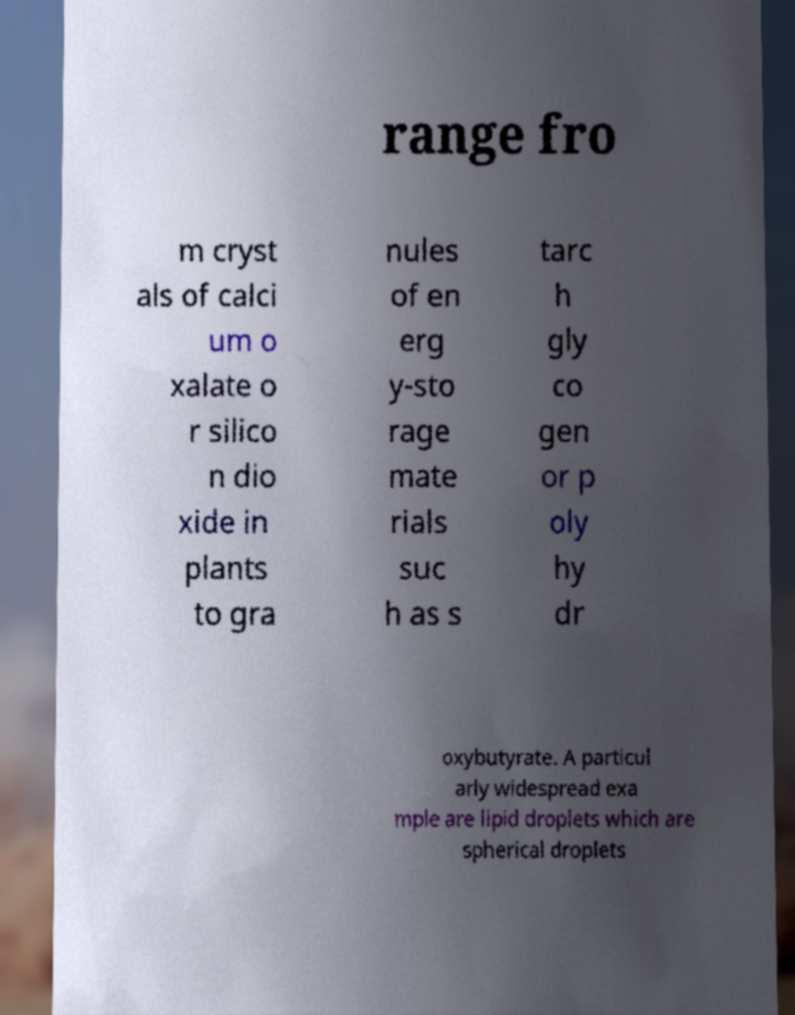Could you extract and type out the text from this image? range fro m cryst als of calci um o xalate o r silico n dio xide in plants to gra nules of en erg y-sto rage mate rials suc h as s tarc h gly co gen or p oly hy dr oxybutyrate. A particul arly widespread exa mple are lipid droplets which are spherical droplets 